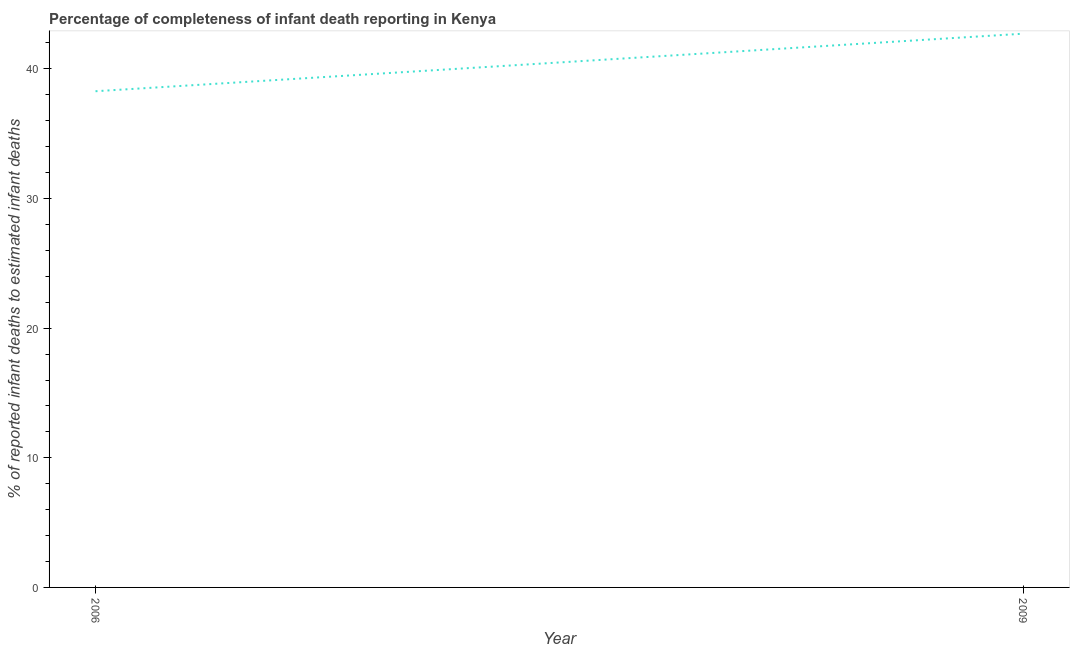What is the completeness of infant death reporting in 2006?
Keep it short and to the point. 38.28. Across all years, what is the maximum completeness of infant death reporting?
Provide a succinct answer. 42.71. Across all years, what is the minimum completeness of infant death reporting?
Provide a short and direct response. 38.28. In which year was the completeness of infant death reporting maximum?
Offer a terse response. 2009. What is the sum of the completeness of infant death reporting?
Offer a very short reply. 80.99. What is the difference between the completeness of infant death reporting in 2006 and 2009?
Make the answer very short. -4.44. What is the average completeness of infant death reporting per year?
Ensure brevity in your answer.  40.5. What is the median completeness of infant death reporting?
Your response must be concise. 40.5. In how many years, is the completeness of infant death reporting greater than 2 %?
Offer a very short reply. 2. Do a majority of the years between 2009 and 2006 (inclusive) have completeness of infant death reporting greater than 38 %?
Ensure brevity in your answer.  No. What is the ratio of the completeness of infant death reporting in 2006 to that in 2009?
Keep it short and to the point. 0.9. In how many years, is the completeness of infant death reporting greater than the average completeness of infant death reporting taken over all years?
Give a very brief answer. 1. How many lines are there?
Offer a very short reply. 1. How many years are there in the graph?
Offer a very short reply. 2. What is the difference between two consecutive major ticks on the Y-axis?
Your response must be concise. 10. Are the values on the major ticks of Y-axis written in scientific E-notation?
Provide a succinct answer. No. Does the graph contain any zero values?
Offer a very short reply. No. What is the title of the graph?
Offer a terse response. Percentage of completeness of infant death reporting in Kenya. What is the label or title of the X-axis?
Give a very brief answer. Year. What is the label or title of the Y-axis?
Provide a succinct answer. % of reported infant deaths to estimated infant deaths. What is the % of reported infant deaths to estimated infant deaths of 2006?
Provide a succinct answer. 38.28. What is the % of reported infant deaths to estimated infant deaths of 2009?
Make the answer very short. 42.71. What is the difference between the % of reported infant deaths to estimated infant deaths in 2006 and 2009?
Offer a very short reply. -4.44. What is the ratio of the % of reported infant deaths to estimated infant deaths in 2006 to that in 2009?
Offer a terse response. 0.9. 